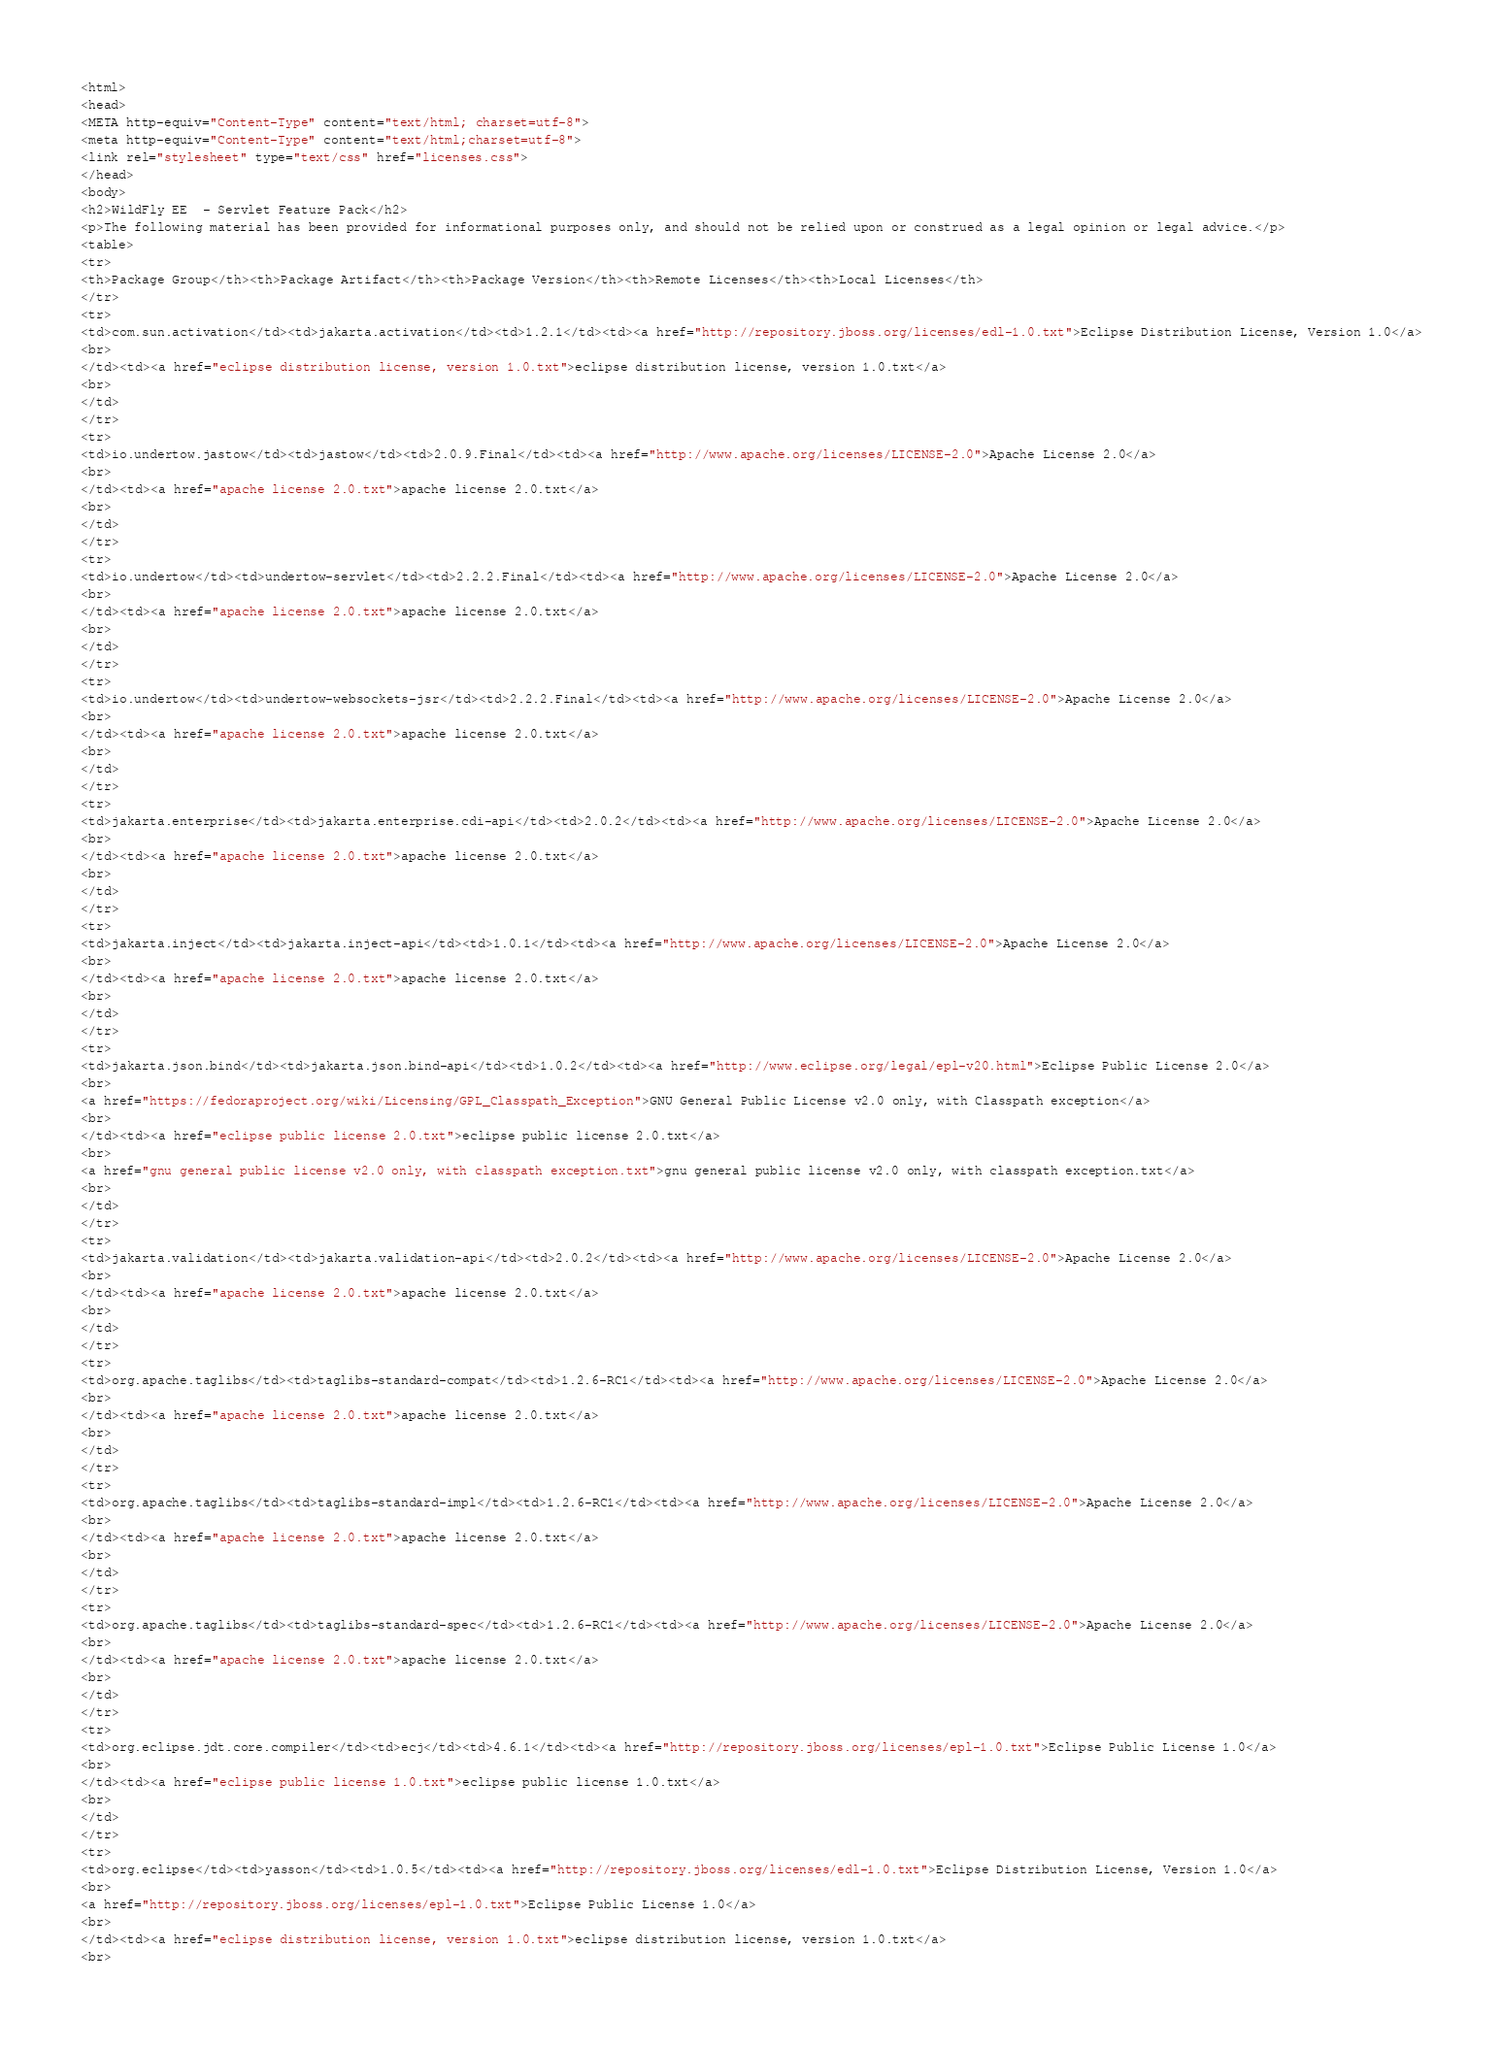<code> <loc_0><loc_0><loc_500><loc_500><_HTML_><html>
<head>
<META http-equiv="Content-Type" content="text/html; charset=utf-8">
<meta http-equiv="Content-Type" content="text/html;charset=utf-8">
<link rel="stylesheet" type="text/css" href="licenses.css">
</head>
<body>
<h2>WildFly EE  - Servlet Feature Pack</h2>
<p>The following material has been provided for informational purposes only, and should not be relied upon or construed as a legal opinion or legal advice.</p>
<table>
<tr>
<th>Package Group</th><th>Package Artifact</th><th>Package Version</th><th>Remote Licenses</th><th>Local Licenses</th>
</tr>
<tr>
<td>com.sun.activation</td><td>jakarta.activation</td><td>1.2.1</td><td><a href="http://repository.jboss.org/licenses/edl-1.0.txt">Eclipse Distribution License, Version 1.0</a>
<br>
</td><td><a href="eclipse distribution license, version 1.0.txt">eclipse distribution license, version 1.0.txt</a>
<br>
</td>
</tr>
<tr>
<td>io.undertow.jastow</td><td>jastow</td><td>2.0.9.Final</td><td><a href="http://www.apache.org/licenses/LICENSE-2.0">Apache License 2.0</a>
<br>
</td><td><a href="apache license 2.0.txt">apache license 2.0.txt</a>
<br>
</td>
</tr>
<tr>
<td>io.undertow</td><td>undertow-servlet</td><td>2.2.2.Final</td><td><a href="http://www.apache.org/licenses/LICENSE-2.0">Apache License 2.0</a>
<br>
</td><td><a href="apache license 2.0.txt">apache license 2.0.txt</a>
<br>
</td>
</tr>
<tr>
<td>io.undertow</td><td>undertow-websockets-jsr</td><td>2.2.2.Final</td><td><a href="http://www.apache.org/licenses/LICENSE-2.0">Apache License 2.0</a>
<br>
</td><td><a href="apache license 2.0.txt">apache license 2.0.txt</a>
<br>
</td>
</tr>
<tr>
<td>jakarta.enterprise</td><td>jakarta.enterprise.cdi-api</td><td>2.0.2</td><td><a href="http://www.apache.org/licenses/LICENSE-2.0">Apache License 2.0</a>
<br>
</td><td><a href="apache license 2.0.txt">apache license 2.0.txt</a>
<br>
</td>
</tr>
<tr>
<td>jakarta.inject</td><td>jakarta.inject-api</td><td>1.0.1</td><td><a href="http://www.apache.org/licenses/LICENSE-2.0">Apache License 2.0</a>
<br>
</td><td><a href="apache license 2.0.txt">apache license 2.0.txt</a>
<br>
</td>
</tr>
<tr>
<td>jakarta.json.bind</td><td>jakarta.json.bind-api</td><td>1.0.2</td><td><a href="http://www.eclipse.org/legal/epl-v20.html">Eclipse Public License 2.0</a>
<br>
<a href="https://fedoraproject.org/wiki/Licensing/GPL_Classpath_Exception">GNU General Public License v2.0 only, with Classpath exception</a>
<br>
</td><td><a href="eclipse public license 2.0.txt">eclipse public license 2.0.txt</a>
<br>
<a href="gnu general public license v2.0 only, with classpath exception.txt">gnu general public license v2.0 only, with classpath exception.txt</a>
<br>
</td>
</tr>
<tr>
<td>jakarta.validation</td><td>jakarta.validation-api</td><td>2.0.2</td><td><a href="http://www.apache.org/licenses/LICENSE-2.0">Apache License 2.0</a>
<br>
</td><td><a href="apache license 2.0.txt">apache license 2.0.txt</a>
<br>
</td>
</tr>
<tr>
<td>org.apache.taglibs</td><td>taglibs-standard-compat</td><td>1.2.6-RC1</td><td><a href="http://www.apache.org/licenses/LICENSE-2.0">Apache License 2.0</a>
<br>
</td><td><a href="apache license 2.0.txt">apache license 2.0.txt</a>
<br>
</td>
</tr>
<tr>
<td>org.apache.taglibs</td><td>taglibs-standard-impl</td><td>1.2.6-RC1</td><td><a href="http://www.apache.org/licenses/LICENSE-2.0">Apache License 2.0</a>
<br>
</td><td><a href="apache license 2.0.txt">apache license 2.0.txt</a>
<br>
</td>
</tr>
<tr>
<td>org.apache.taglibs</td><td>taglibs-standard-spec</td><td>1.2.6-RC1</td><td><a href="http://www.apache.org/licenses/LICENSE-2.0">Apache License 2.0</a>
<br>
</td><td><a href="apache license 2.0.txt">apache license 2.0.txt</a>
<br>
</td>
</tr>
<tr>
<td>org.eclipse.jdt.core.compiler</td><td>ecj</td><td>4.6.1</td><td><a href="http://repository.jboss.org/licenses/epl-1.0.txt">Eclipse Public License 1.0</a>
<br>
</td><td><a href="eclipse public license 1.0.txt">eclipse public license 1.0.txt</a>
<br>
</td>
</tr>
<tr>
<td>org.eclipse</td><td>yasson</td><td>1.0.5</td><td><a href="http://repository.jboss.org/licenses/edl-1.0.txt">Eclipse Distribution License, Version 1.0</a>
<br>
<a href="http://repository.jboss.org/licenses/epl-1.0.txt">Eclipse Public License 1.0</a>
<br>
</td><td><a href="eclipse distribution license, version 1.0.txt">eclipse distribution license, version 1.0.txt</a>
<br></code> 